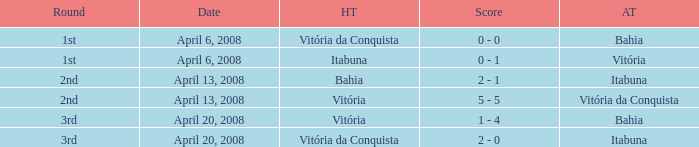Parse the table in full. {'header': ['Round', 'Date', 'HT', 'Score', 'AT'], 'rows': [['1st', 'April 6, 2008', 'Vitória da Conquista', '0 - 0', 'Bahia'], ['1st', 'April 6, 2008', 'Itabuna', '0 - 1', 'Vitória'], ['2nd', 'April 13, 2008', 'Bahia', '2 - 1', 'Itabuna'], ['2nd', 'April 13, 2008', 'Vitória', '5 - 5', 'Vitória da Conquista'], ['3rd', 'April 20, 2008', 'Vitória', '1 - 4', 'Bahia'], ['3rd', 'April 20, 2008', 'Vitória da Conquista', '2 - 0', 'Itabuna']]} Who played as the home team when Vitória was the away team? Itabuna. 